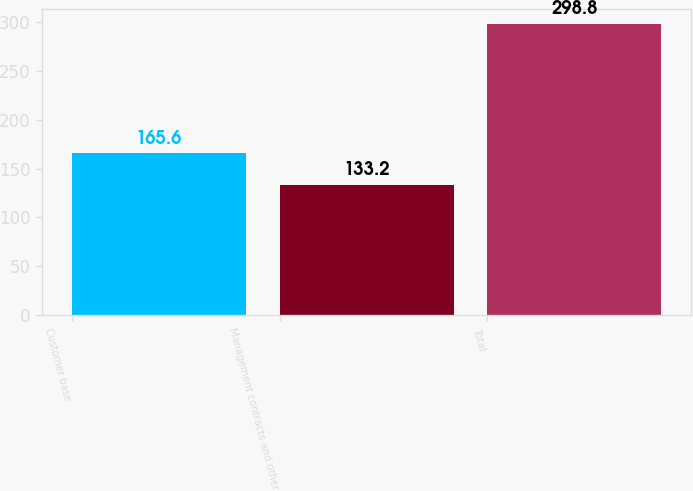Convert chart to OTSL. <chart><loc_0><loc_0><loc_500><loc_500><bar_chart><fcel>Customer base<fcel>Management contracts and other<fcel>Total<nl><fcel>165.6<fcel>133.2<fcel>298.8<nl></chart> 